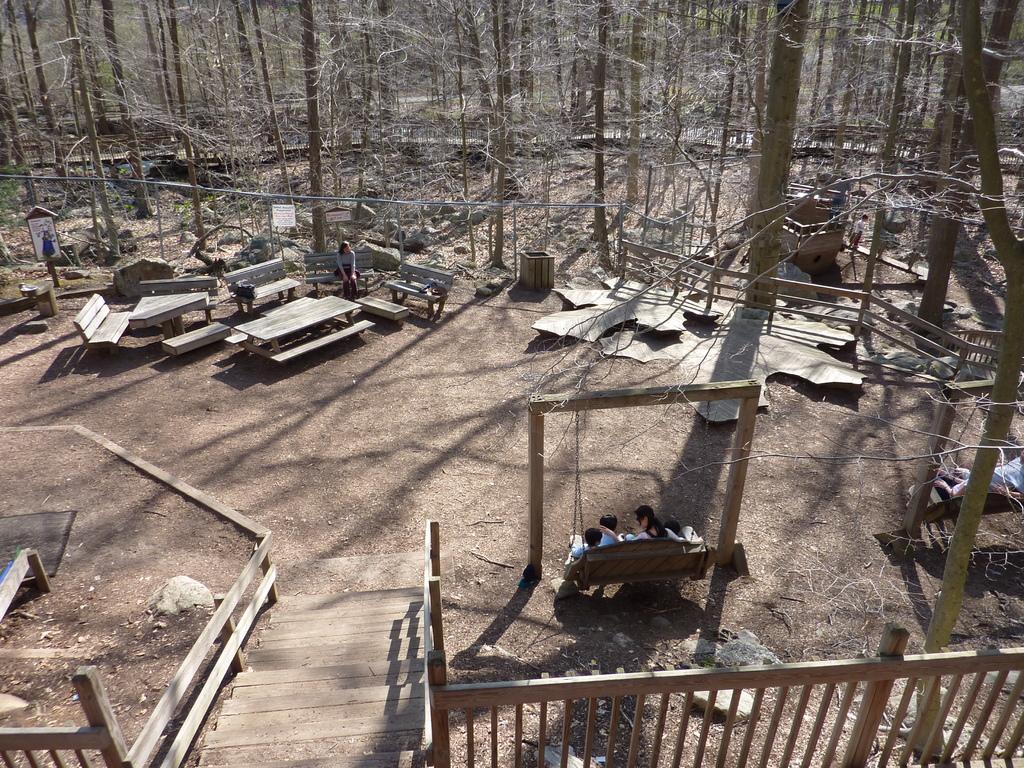Describe this image in one or two sentences. At the bottom we can see steps and fence. On the right there are two single swing frames and few persons are sitting on it. In the background there is a woman sitting on the wooden bench and there are wooden benches,tables,bare trees and a person is standing on the right side and there are other objects. 